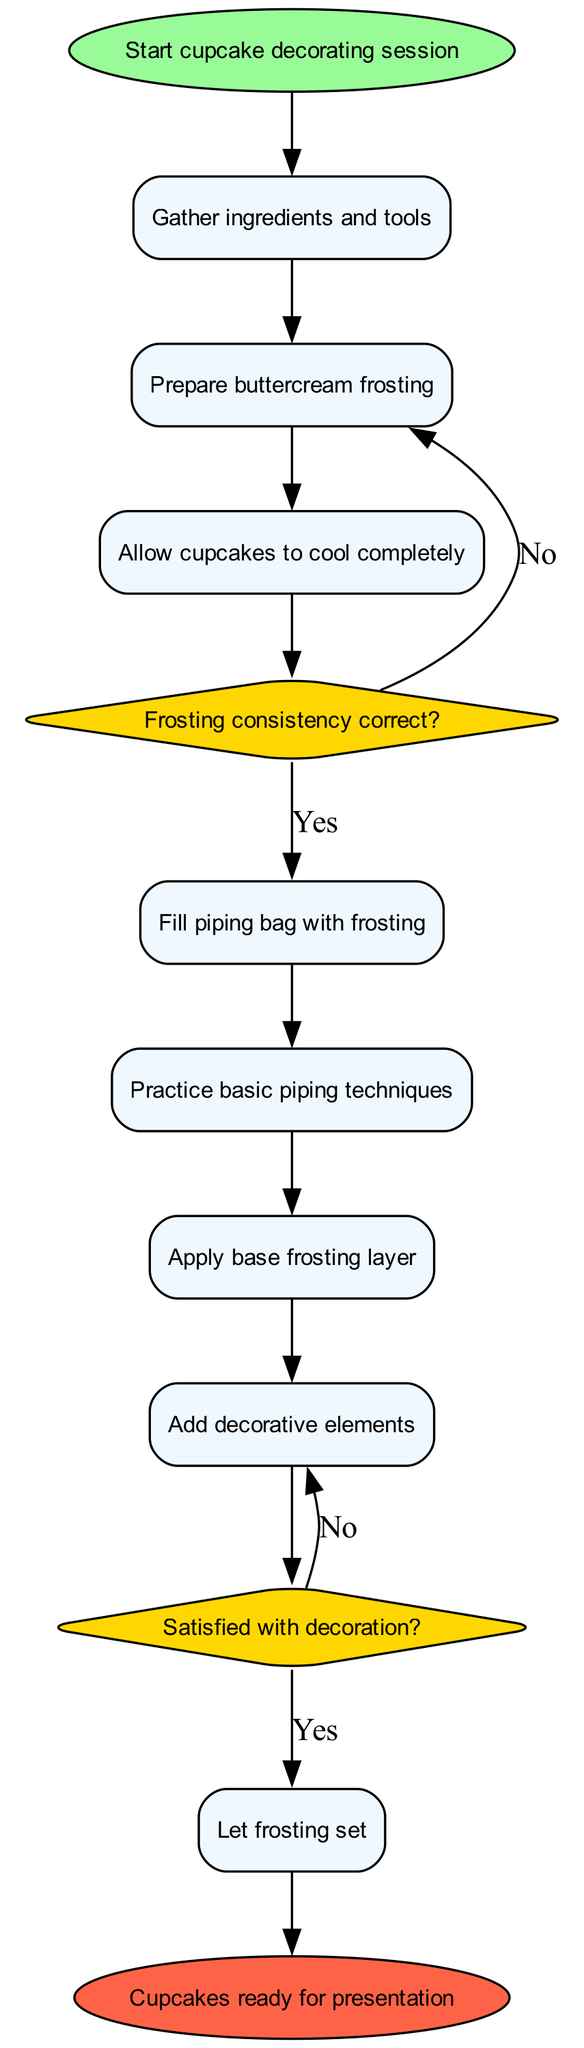What is the starting node of the diagram? The starting node is labeled "Start cupcake decorating session." By looking at the diagram, the first node presented is the one that indicates the beginning of the cupcake decorating process.
Answer: Start cupcake decorating session How many activities are involved in the decorating session? There are eight activities listed in the diagram, as each one is outlined in the activities section. Counting them gives a total of eight.
Answer: 8 What is the first activity after the start node? The first activity following the start node is "Gather ingredients and tools." By tracing the arrow from the start node, the flow leads directly to this activity.
Answer: Gather ingredients and tools What happens if the frosting consistency is not correct? If the frosting consistency is "No," the next step is to "Adjust frosting consistency." This outcome is represented in the decision section, indicating the corrective action taken if the frosting does not meet the standard.
Answer: Adjust frosting consistency How many decision nodes are present in the diagram? There are two decision nodes in the diagram. They are specifically indicated as diamond shapes representing points that require a choice to be made in the decorating process.
Answer: 2 What is the final action before the end node? The final action before reaching the end node is "Let frosting set." This is the last process that occurs before the cupcakes are ready for presentation, according to the diagram's flow.
Answer: Let frosting set If the decoration is not satisfactory, what is the next step? If the decoration is "No," the next action is to "Add more decorative elements," as per the decision flow in the diagram. This indicates an iteration in decorating until satisfaction is achieved.
Answer: Add more decorative elements What color represents the end node in the diagram? The end node is represented in a red color, specifically "Cupcakes ready for presentation" is in a shape filled with this color. This visual distinction marks the conclusion of the activities.
Answer: Red What activity immediately follows filling the piping bag with frosting? After "Fill piping bag with frosting," the next activity is "Practice basic piping techniques," as indicated by the flow sequence in the diagram.
Answer: Practice basic piping techniques 